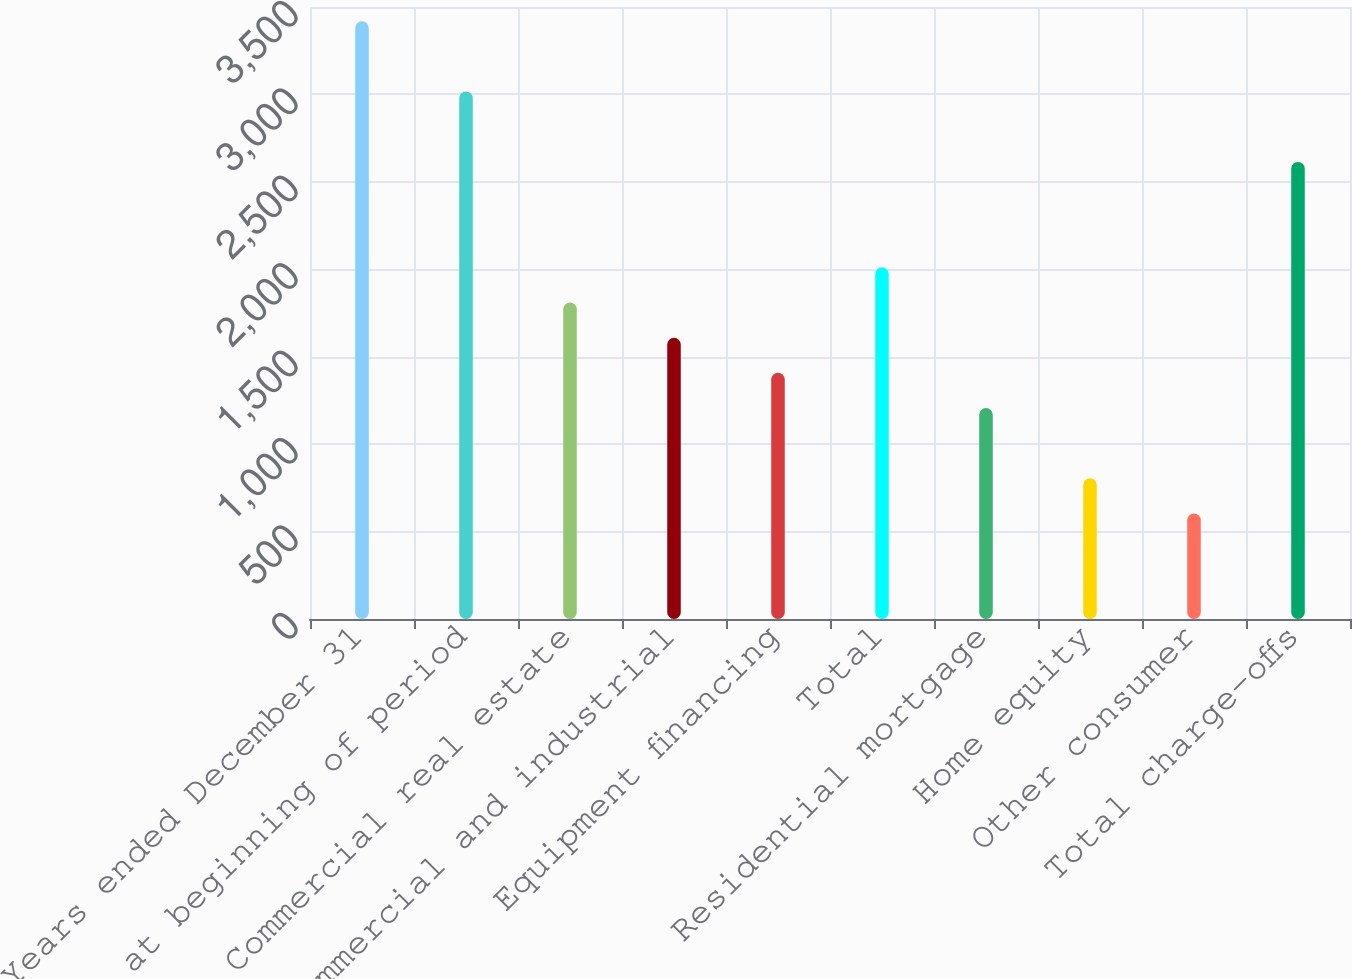Convert chart to OTSL. <chart><loc_0><loc_0><loc_500><loc_500><bar_chart><fcel>Years ended December 31<fcel>Balance at beginning of period<fcel>Commercial real estate<fcel>Commercial and industrial<fcel>Equipment financing<fcel>Total<fcel>Residential mortgage<fcel>Home equity<fcel>Other consumer<fcel>Total charge-offs<nl><fcel>3418.48<fcel>3016.34<fcel>1809.92<fcel>1608.85<fcel>1407.78<fcel>2010.99<fcel>1206.71<fcel>804.57<fcel>603.5<fcel>2614.2<nl></chart> 